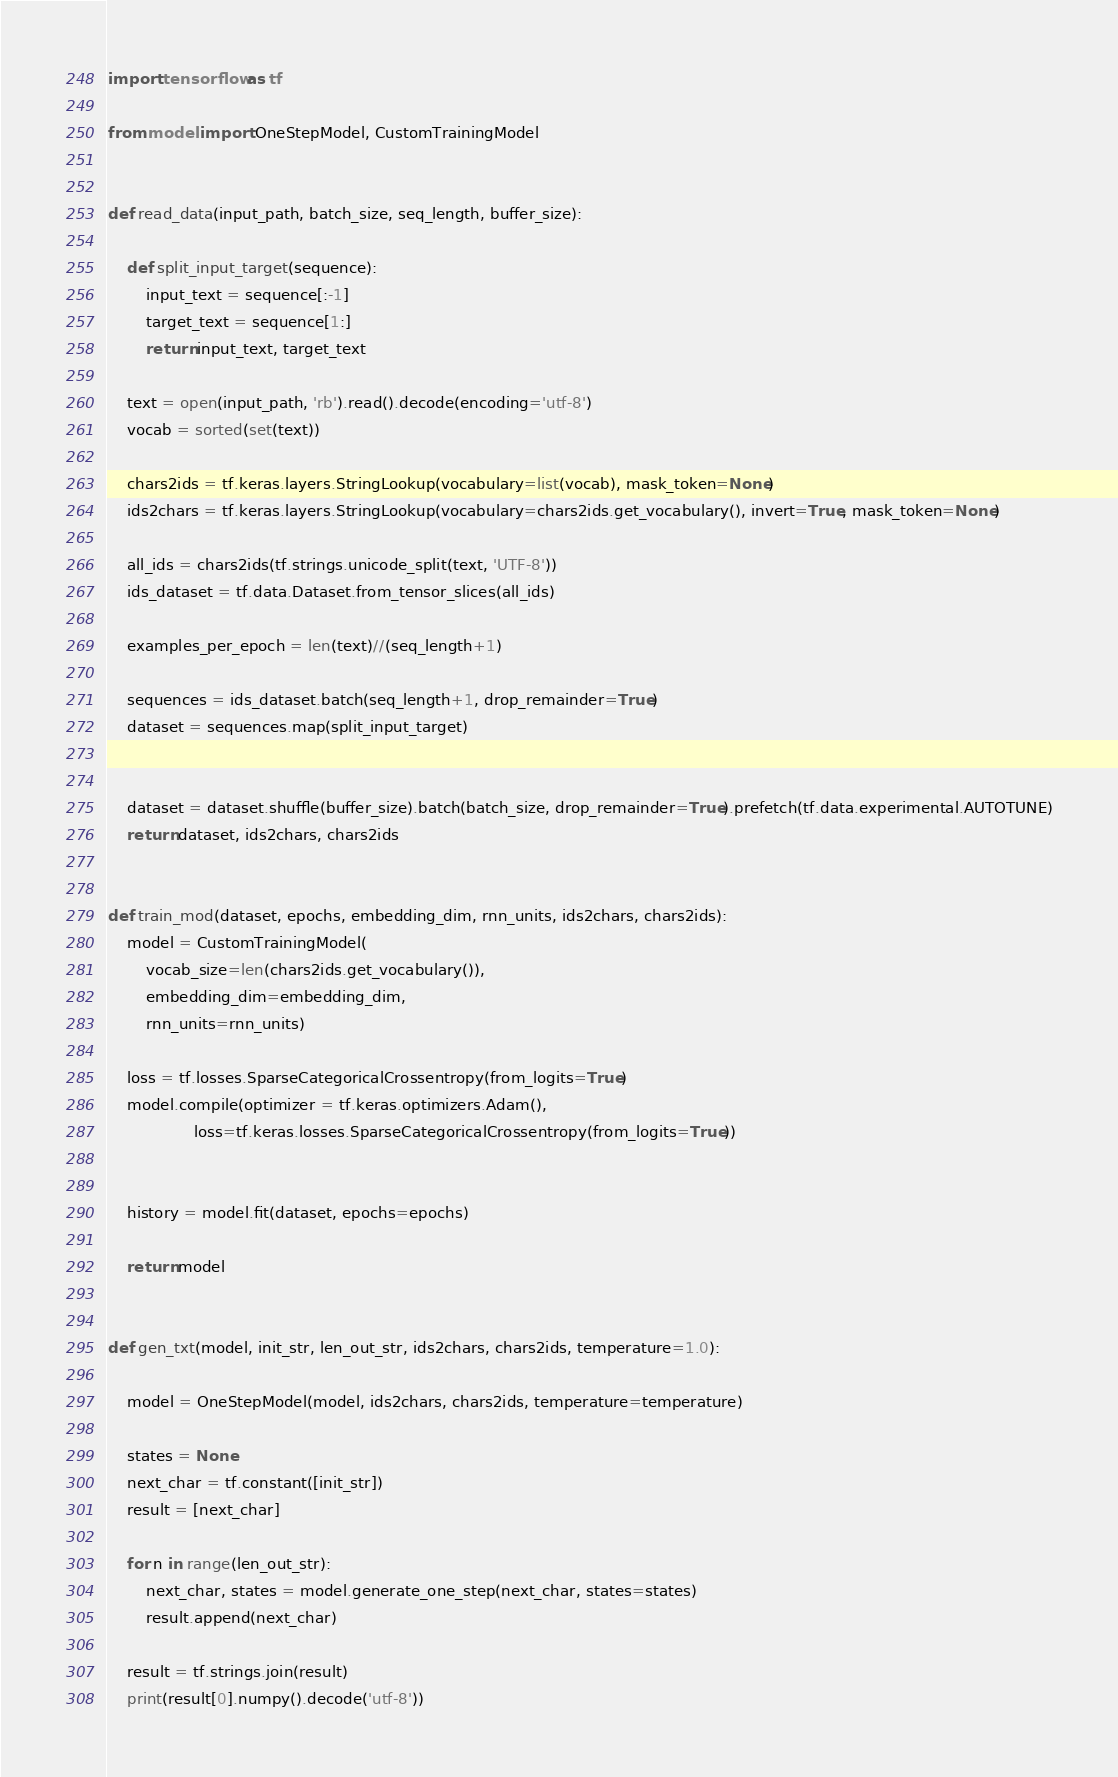Convert code to text. <code><loc_0><loc_0><loc_500><loc_500><_Python_>import tensorflow as tf

from model import OneStepModel, CustomTrainingModel


def read_data(input_path, batch_size, seq_length, buffer_size):
    
    def split_input_target(sequence):
        input_text = sequence[:-1]
        target_text = sequence[1:]
        return input_text, target_text

    text = open(input_path, 'rb').read().decode(encoding='utf-8')
    vocab = sorted(set(text))

    chars2ids = tf.keras.layers.StringLookup(vocabulary=list(vocab), mask_token=None)
    ids2chars = tf.keras.layers.StringLookup(vocabulary=chars2ids.get_vocabulary(), invert=True, mask_token=None)

    all_ids = chars2ids(tf.strings.unicode_split(text, 'UTF-8'))
    ids_dataset = tf.data.Dataset.from_tensor_slices(all_ids)
    
    examples_per_epoch = len(text)//(seq_length+1)

    sequences = ids_dataset.batch(seq_length+1, drop_remainder=True)
    dataset = sequences.map(split_input_target)


    dataset = dataset.shuffle(buffer_size).batch(batch_size, drop_remainder=True).prefetch(tf.data.experimental.AUTOTUNE)
    return dataset, ids2chars, chars2ids


def train_mod(dataset, epochs, embedding_dim, rnn_units, ids2chars, chars2ids):
    model = CustomTrainingModel(
        vocab_size=len(chars2ids.get_vocabulary()),
        embedding_dim=embedding_dim,
        rnn_units=rnn_units)
    
    loss = tf.losses.SparseCategoricalCrossentropy(from_logits=True)
    model.compile(optimizer = tf.keras.optimizers.Adam(),
                  loss=tf.keras.losses.SparseCategoricalCrossentropy(from_logits=True))
    

    history = model.fit(dataset, epochs=epochs)
    
    return model


def gen_txt(model, init_str, len_out_str, ids2chars, chars2ids, temperature=1.0):

    model = OneStepModel(model, ids2chars, chars2ids, temperature=temperature)
    
    states = None
    next_char = tf.constant([init_str])
    result = [next_char]

    for n in range(len_out_str):
        next_char, states = model.generate_one_step(next_char, states=states)
        result.append(next_char)

    result = tf.strings.join(result)
    print(result[0].numpy().decode('utf-8'))
</code> 